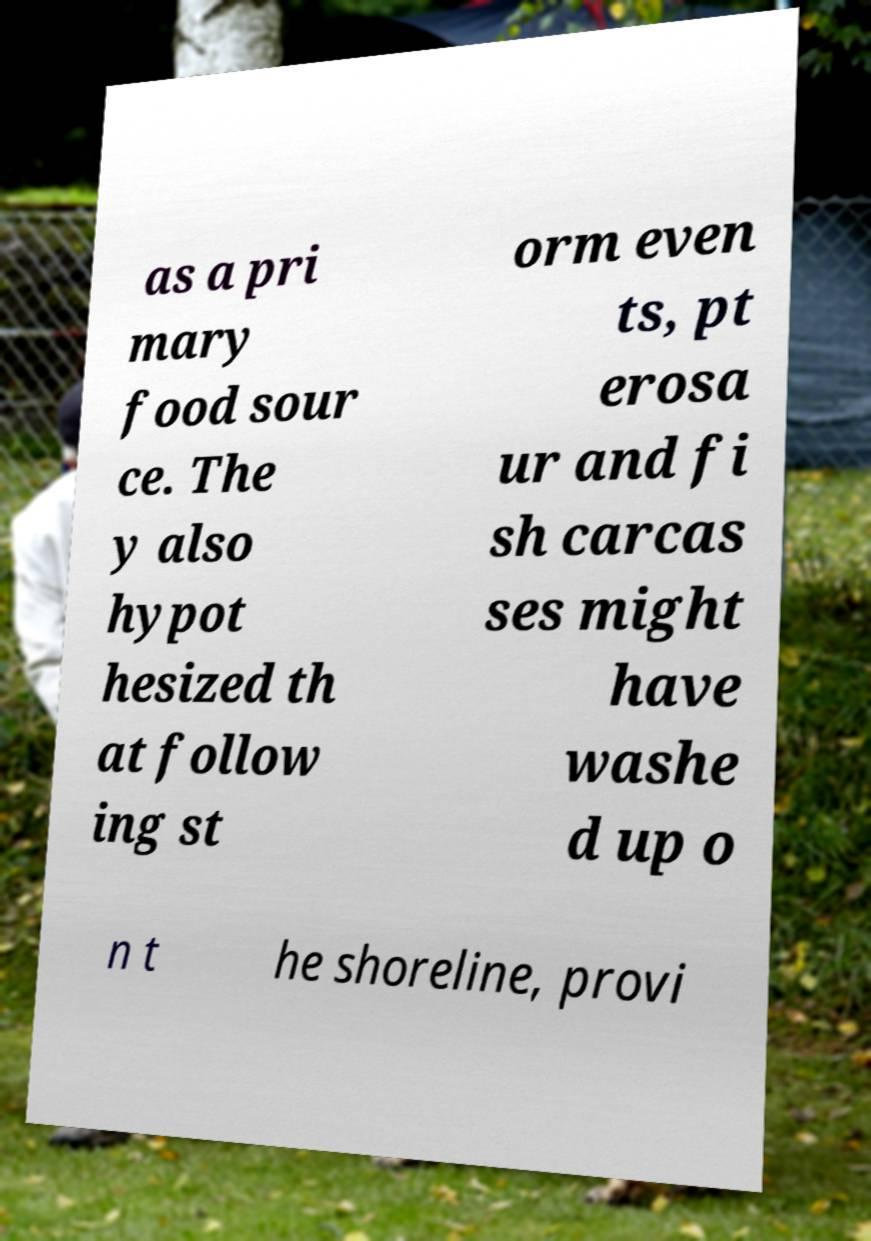What messages or text are displayed in this image? I need them in a readable, typed format. as a pri mary food sour ce. The y also hypot hesized th at follow ing st orm even ts, pt erosa ur and fi sh carcas ses might have washe d up o n t he shoreline, provi 